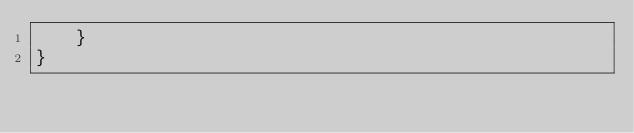<code> <loc_0><loc_0><loc_500><loc_500><_Kotlin_>    }
}</code> 